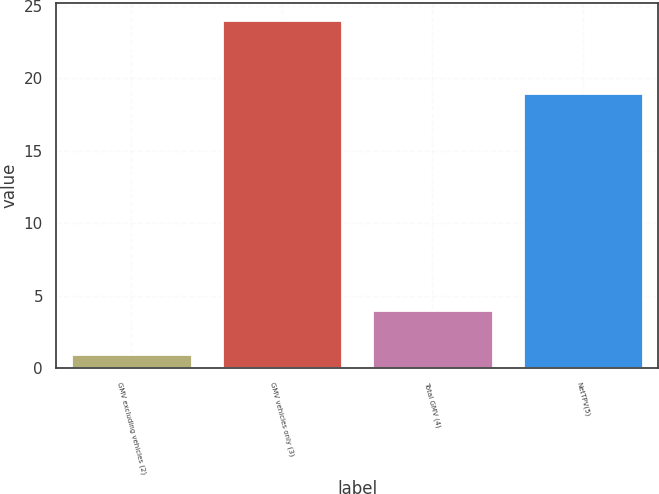Convert chart. <chart><loc_0><loc_0><loc_500><loc_500><bar_chart><fcel>GMV excluding vehicles (2)<fcel>GMV vehicles only (3)<fcel>Total GMV (4)<fcel>NetTPV(5)<nl><fcel>1<fcel>24<fcel>4<fcel>19<nl></chart> 